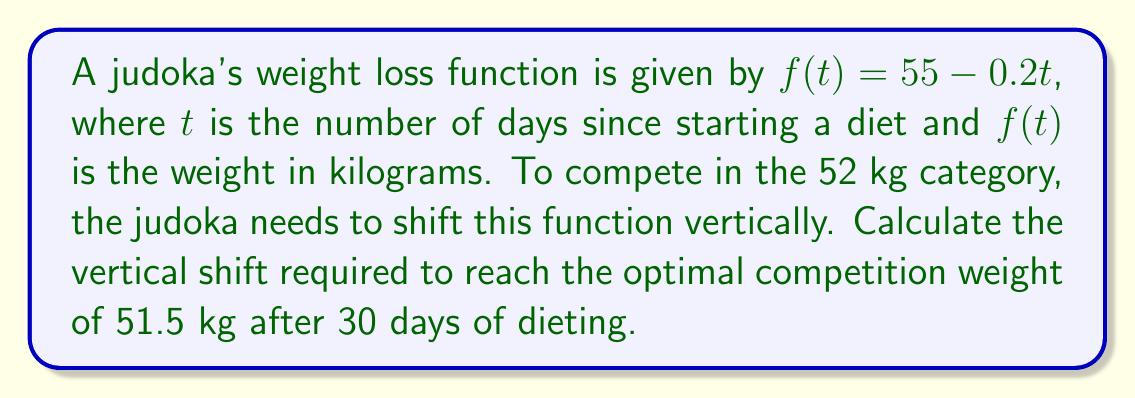Can you answer this question? To solve this problem, we need to follow these steps:

1) First, let's calculate the weight after 30 days without any shift:
   $f(30) = 55 - 0.2(30) = 55 - 6 = 49$ kg

2) The vertical shift is represented by adding or subtracting a constant $k$ to the function:
   $g(t) = f(t) + k = (55 - 0.2t) + k$

3) We want $g(30) = 51.5$ kg (the optimal competition weight). So:
   $g(30) = f(30) + k = 51.5$
   $49 + k = 51.5$

4) Solve for $k$:
   $k = 51.5 - 49 = 2.5$

5) Therefore, the function needs to be shifted up by 2.5 units.

The new function would be:
$g(t) = f(t) + 2.5 = (55 - 0.2t) + 2.5 = 57.5 - 0.2t$

This ensures that after 30 days, the judoka's weight will be 51.5 kg, which is optimal for the 52 kg category.
Answer: The required vertical shift is $+2.5$ kg upward. 